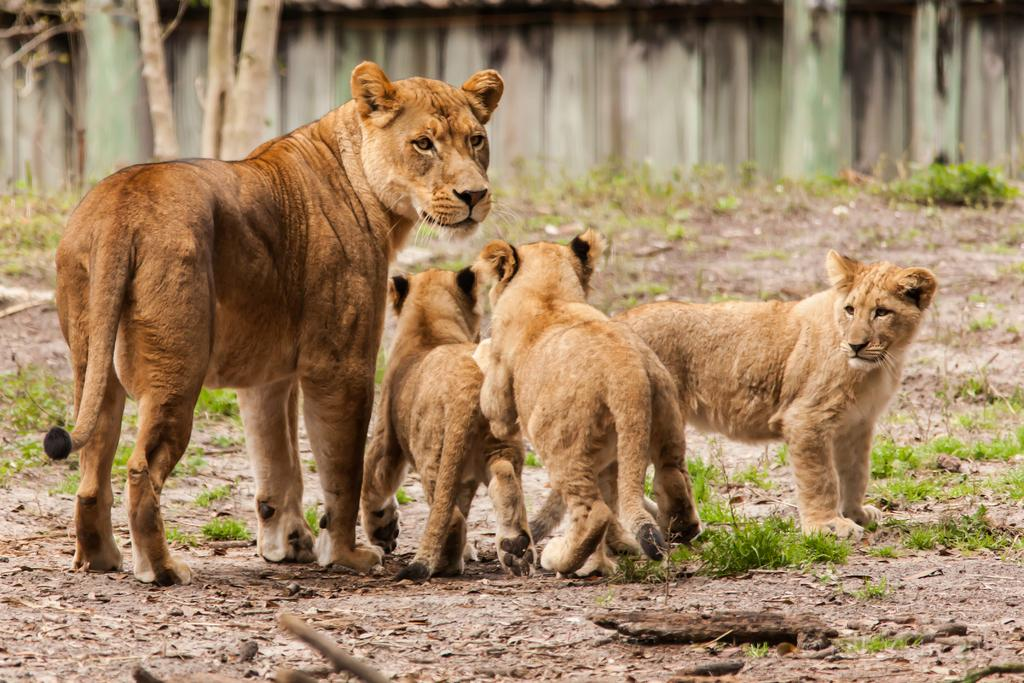What animals are present in the image? There are lions in the image. What is the lions' position in relation to the ground? The lions are standing on the ground. Can you describe any other elements in the background of the image? Unfortunately, the provided facts do not give any information about the objects in the background. What type of trail can be seen behind the lions in the image? There is no trail visible behind the lions in the image. 